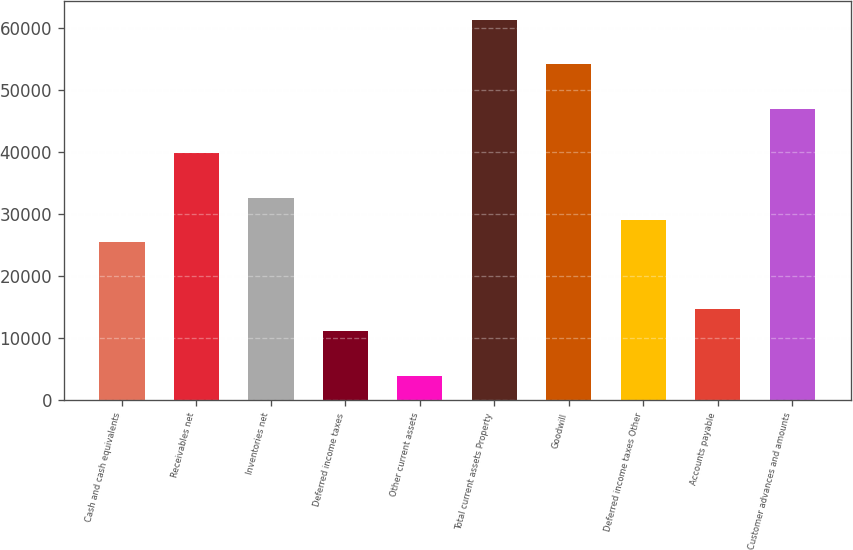<chart> <loc_0><loc_0><loc_500><loc_500><bar_chart><fcel>Cash and cash equivalents<fcel>Receivables net<fcel>Inventories net<fcel>Deferred income taxes<fcel>Other current assets<fcel>Total current assets Property<fcel>Goodwill<fcel>Deferred income taxes Other<fcel>Accounts payable<fcel>Customer advances and amounts<nl><fcel>25427.3<fcel>39774.9<fcel>32601.1<fcel>11079.7<fcel>3905.9<fcel>61296.3<fcel>54122.5<fcel>29014.2<fcel>14666.6<fcel>46948.7<nl></chart> 